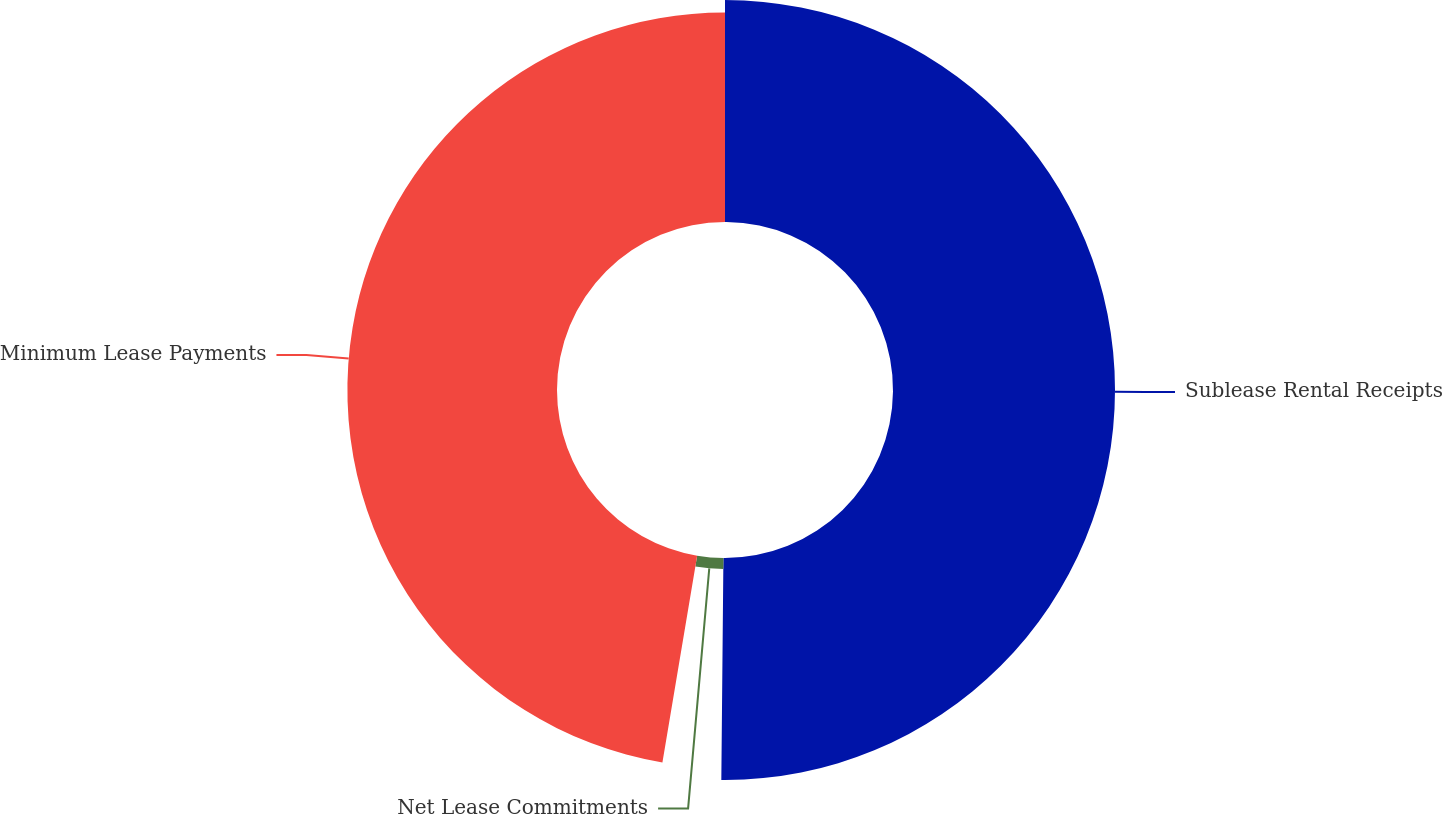Convert chart to OTSL. <chart><loc_0><loc_0><loc_500><loc_500><pie_chart><fcel>Sublease Rental Receipts<fcel>Net Lease Commitments<fcel>Minimum Lease Payments<nl><fcel>50.15%<fcel>2.5%<fcel>47.35%<nl></chart> 